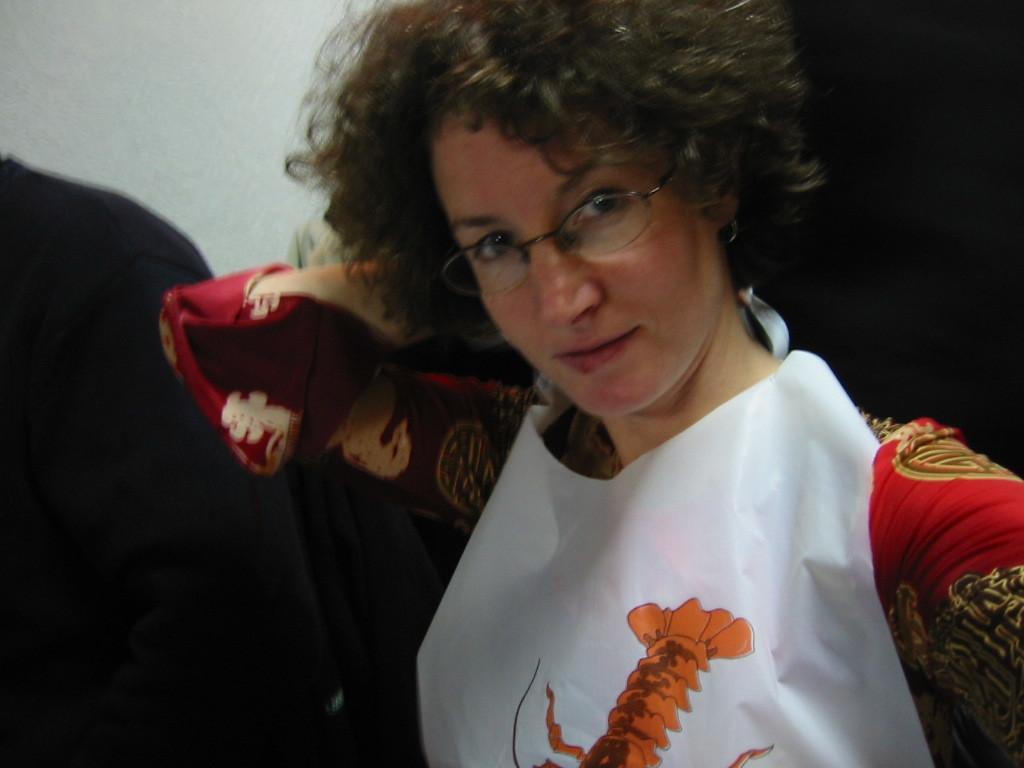Could you give a brief overview of what you see in this image? In this image I can see a woman wearing red color dress and looking at the picture. In the background I can see a person. On the top of the image there is a wall. 